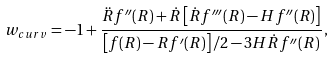<formula> <loc_0><loc_0><loc_500><loc_500>w _ { c u r v } = - 1 + \frac { \ddot { R } f ^ { \prime \prime } ( R ) + \dot { R } \left [ \dot { R } f ^ { \prime \prime \prime } ( R ) - H f ^ { \prime \prime } ( R ) \right ] } { \left [ f ( R ) - R f ^ { \prime } ( R ) \right ] / 2 - 3 H \dot { R } f ^ { \prime \prime } ( R ) } \, ,</formula> 